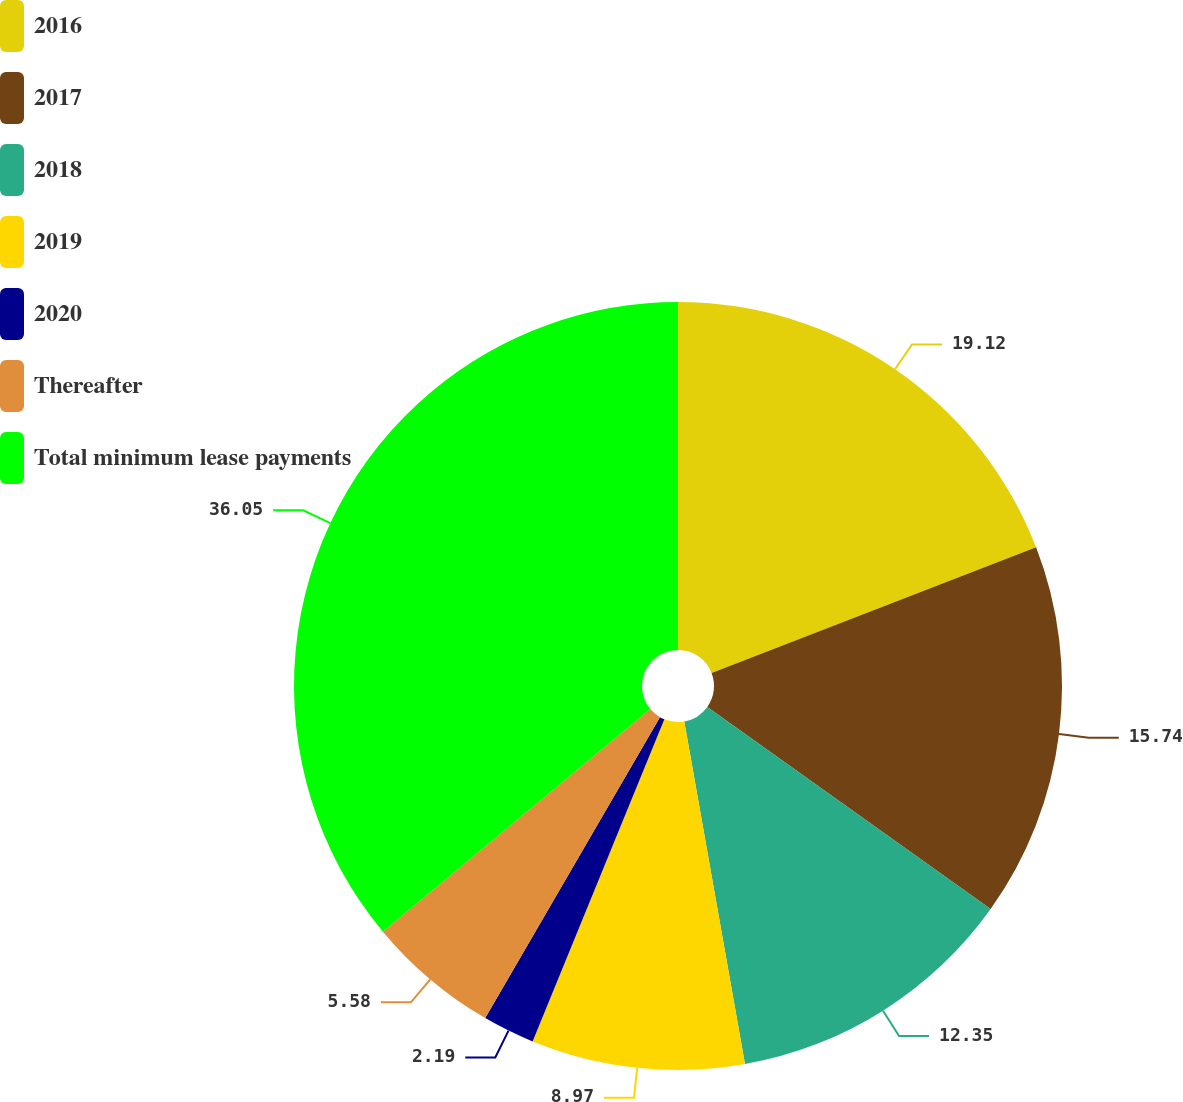<chart> <loc_0><loc_0><loc_500><loc_500><pie_chart><fcel>2016<fcel>2017<fcel>2018<fcel>2019<fcel>2020<fcel>Thereafter<fcel>Total minimum lease payments<nl><fcel>19.12%<fcel>15.74%<fcel>12.35%<fcel>8.97%<fcel>2.19%<fcel>5.58%<fcel>36.05%<nl></chart> 